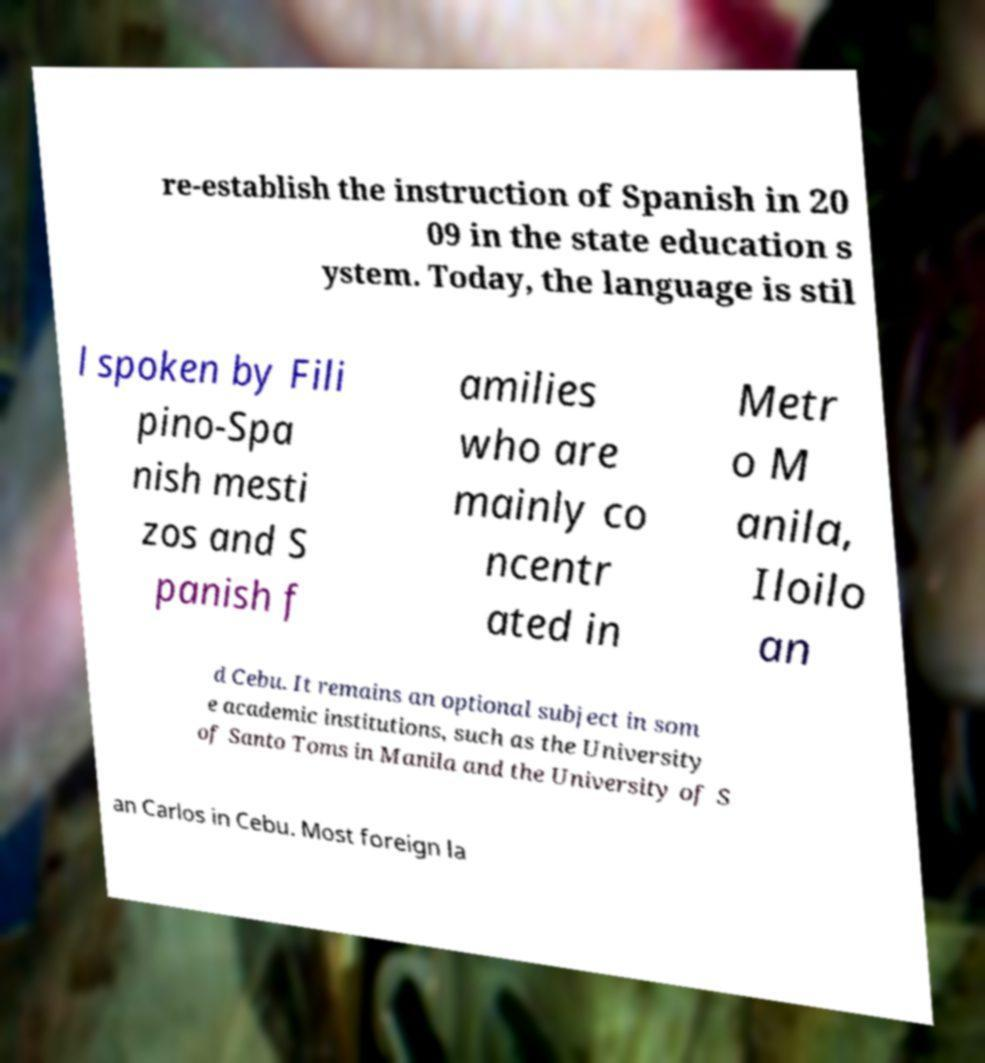Please read and relay the text visible in this image. What does it say? re-establish the instruction of Spanish in 20 09 in the state education s ystem. Today, the language is stil l spoken by Fili pino-Spa nish mesti zos and S panish f amilies who are mainly co ncentr ated in Metr o M anila, Iloilo an d Cebu. It remains an optional subject in som e academic institutions, such as the University of Santo Toms in Manila and the University of S an Carlos in Cebu. Most foreign la 